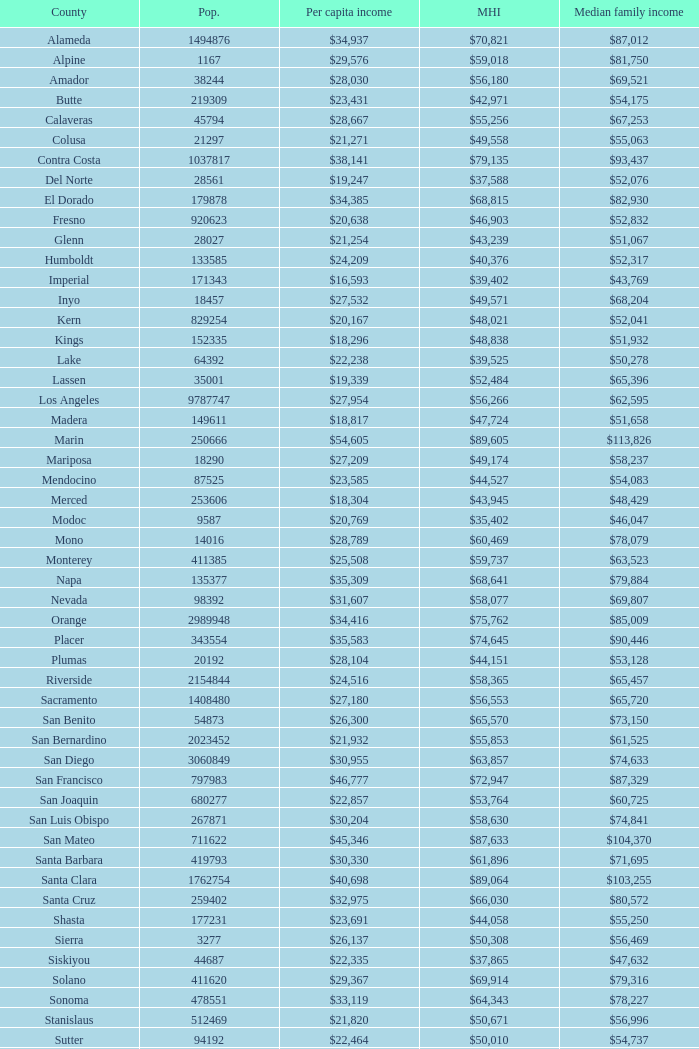What is the median household income of butte? $42,971. 